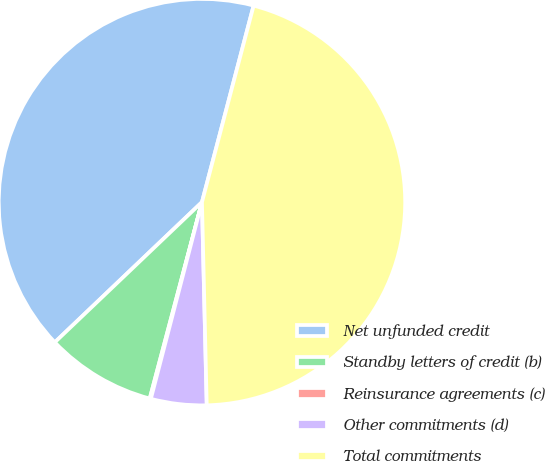<chart> <loc_0><loc_0><loc_500><loc_500><pie_chart><fcel>Net unfunded credit<fcel>Standby letters of credit (b)<fcel>Reinsurance agreements (c)<fcel>Other commitments (d)<fcel>Total commitments<nl><fcel>41.2%<fcel>8.75%<fcel>0.09%<fcel>4.42%<fcel>45.53%<nl></chart> 